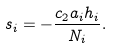Convert formula to latex. <formula><loc_0><loc_0><loc_500><loc_500>s _ { i } = - \frac { c _ { 2 } a _ { i } h _ { i } } { N _ { i } } .</formula> 